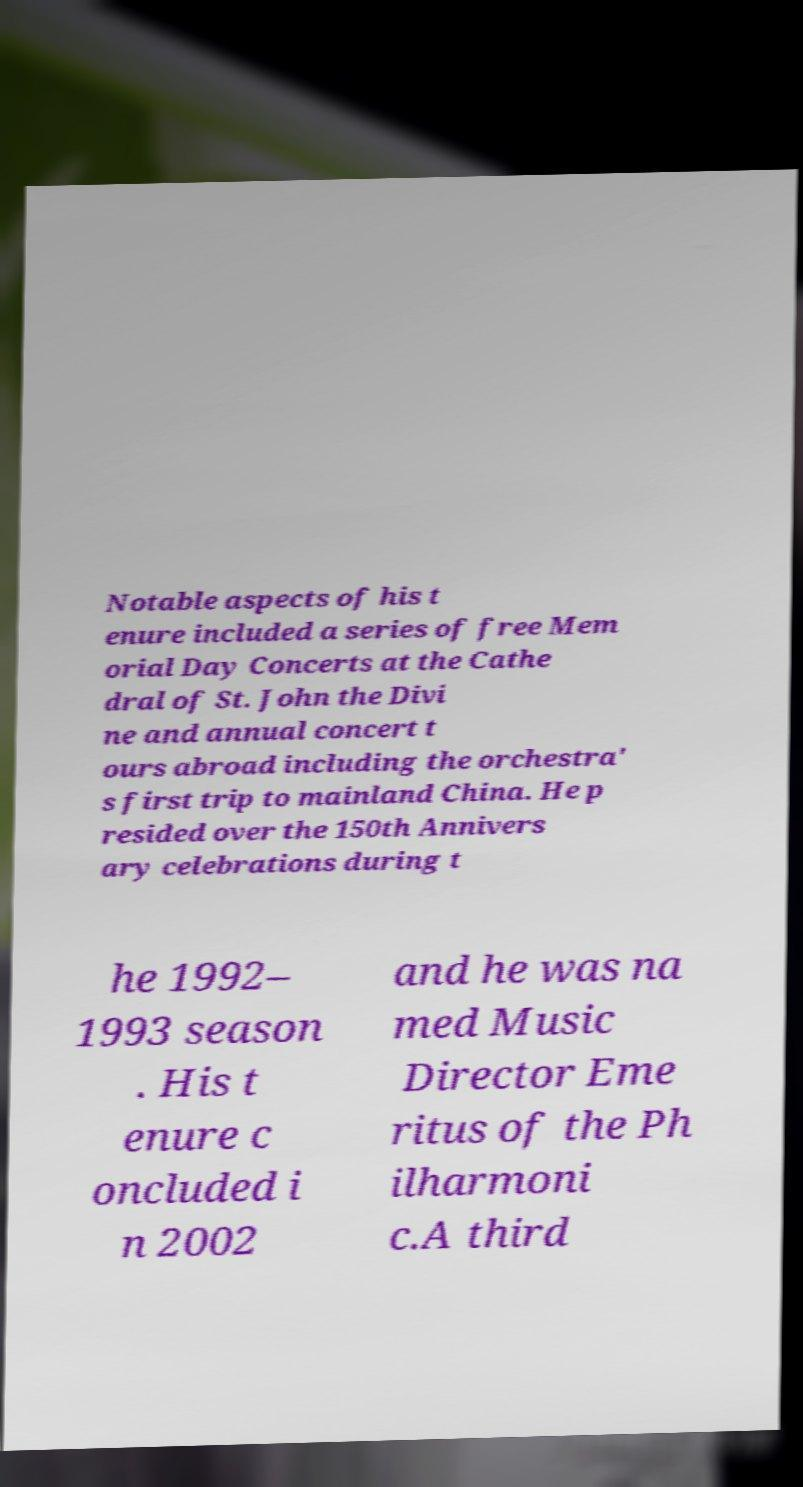Could you extract and type out the text from this image? Notable aspects of his t enure included a series of free Mem orial Day Concerts at the Cathe dral of St. John the Divi ne and annual concert t ours abroad including the orchestra' s first trip to mainland China. He p resided over the 150th Annivers ary celebrations during t he 1992– 1993 season . His t enure c oncluded i n 2002 and he was na med Music Director Eme ritus of the Ph ilharmoni c.A third 